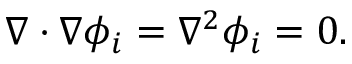<formula> <loc_0><loc_0><loc_500><loc_500>\nabla \cdot \nabla \phi _ { i } = \nabla ^ { 2 } \phi _ { i } = 0 .</formula> 